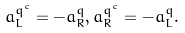Convert formula to latex. <formula><loc_0><loc_0><loc_500><loc_500>a _ { L } ^ { q ^ { c } } = - a _ { R } ^ { q } , a _ { R } ^ { q ^ { c } } = - a _ { L } ^ { q } .</formula> 